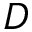<formula> <loc_0><loc_0><loc_500><loc_500>D</formula> 